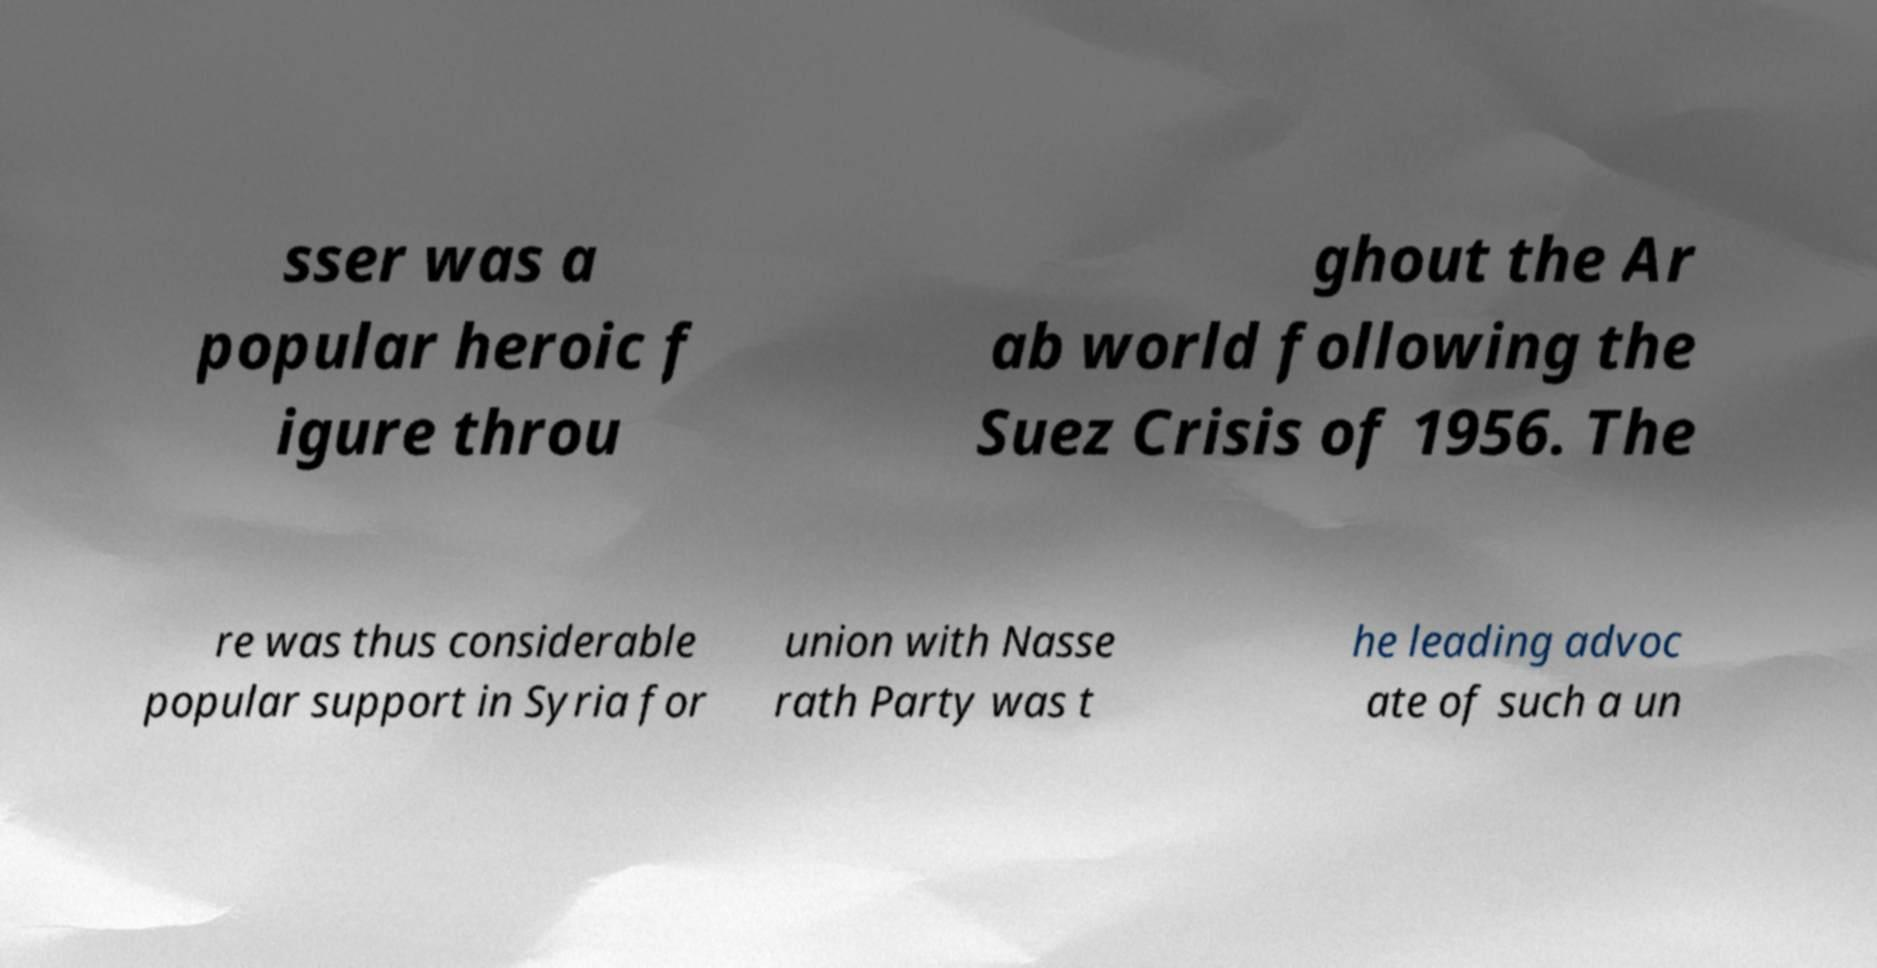Could you assist in decoding the text presented in this image and type it out clearly? sser was a popular heroic f igure throu ghout the Ar ab world following the Suez Crisis of 1956. The re was thus considerable popular support in Syria for union with Nasse rath Party was t he leading advoc ate of such a un 